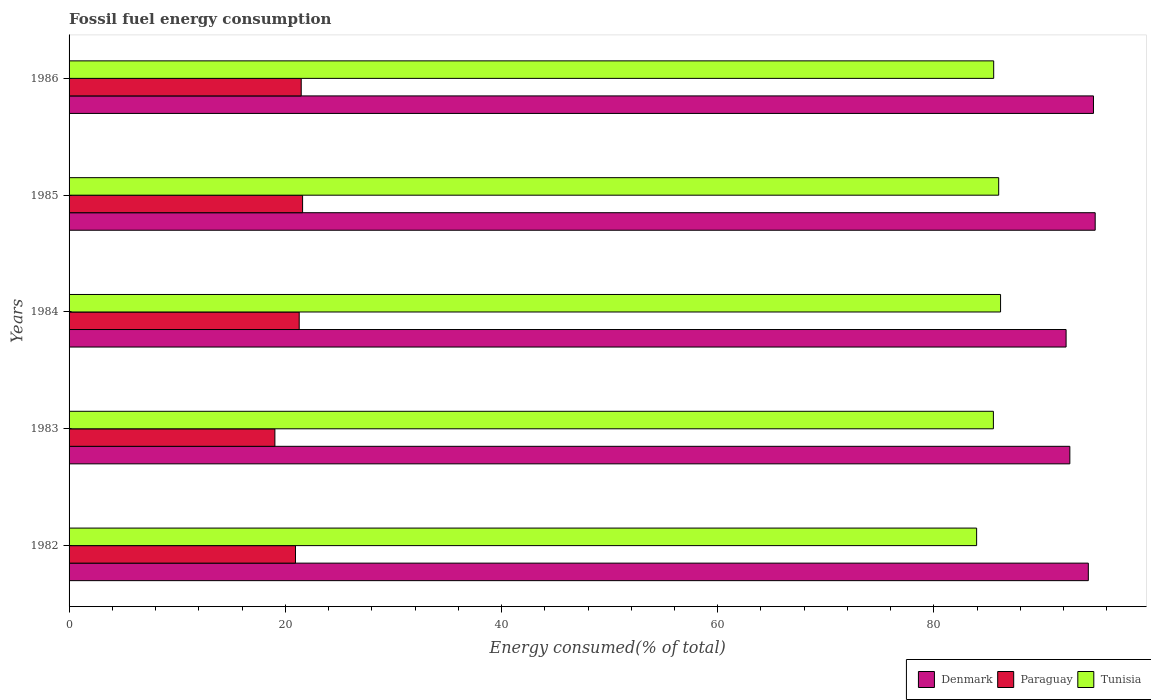How many different coloured bars are there?
Make the answer very short. 3. How many groups of bars are there?
Make the answer very short. 5. Are the number of bars per tick equal to the number of legend labels?
Offer a very short reply. Yes. Are the number of bars on each tick of the Y-axis equal?
Offer a terse response. Yes. How many bars are there on the 5th tick from the top?
Your response must be concise. 3. What is the label of the 5th group of bars from the top?
Make the answer very short. 1982. What is the percentage of energy consumed in Paraguay in 1985?
Your answer should be compact. 21.6. Across all years, what is the maximum percentage of energy consumed in Paraguay?
Give a very brief answer. 21.6. Across all years, what is the minimum percentage of energy consumed in Denmark?
Provide a short and direct response. 92.22. In which year was the percentage of energy consumed in Tunisia maximum?
Provide a succinct answer. 1984. In which year was the percentage of energy consumed in Denmark minimum?
Your answer should be very brief. 1984. What is the total percentage of energy consumed in Tunisia in the graph?
Your response must be concise. 427.12. What is the difference between the percentage of energy consumed in Paraguay in 1982 and that in 1986?
Provide a short and direct response. -0.53. What is the difference between the percentage of energy consumed in Denmark in 1985 and the percentage of energy consumed in Tunisia in 1983?
Offer a terse response. 9.42. What is the average percentage of energy consumed in Tunisia per year?
Provide a succinct answer. 85.42. In the year 1983, what is the difference between the percentage of energy consumed in Paraguay and percentage of energy consumed in Tunisia?
Ensure brevity in your answer.  -66.46. In how many years, is the percentage of energy consumed in Tunisia greater than 60 %?
Give a very brief answer. 5. What is the ratio of the percentage of energy consumed in Denmark in 1982 to that in 1984?
Offer a very short reply. 1.02. Is the percentage of energy consumed in Denmark in 1984 less than that in 1985?
Make the answer very short. Yes. Is the difference between the percentage of energy consumed in Paraguay in 1982 and 1984 greater than the difference between the percentage of energy consumed in Tunisia in 1982 and 1984?
Give a very brief answer. Yes. What is the difference between the highest and the second highest percentage of energy consumed in Tunisia?
Your answer should be very brief. 0.17. What is the difference between the highest and the lowest percentage of energy consumed in Tunisia?
Provide a succinct answer. 2.21. In how many years, is the percentage of energy consumed in Tunisia greater than the average percentage of energy consumed in Tunisia taken over all years?
Offer a terse response. 4. What does the 2nd bar from the top in 1985 represents?
Your answer should be very brief. Paraguay. What does the 2nd bar from the bottom in 1982 represents?
Give a very brief answer. Paraguay. How many bars are there?
Ensure brevity in your answer.  15. How many years are there in the graph?
Offer a terse response. 5. Does the graph contain grids?
Your answer should be compact. No. How are the legend labels stacked?
Offer a very short reply. Horizontal. What is the title of the graph?
Provide a short and direct response. Fossil fuel energy consumption. Does "Central Europe" appear as one of the legend labels in the graph?
Ensure brevity in your answer.  No. What is the label or title of the X-axis?
Give a very brief answer. Energy consumed(% of total). What is the Energy consumed(% of total) in Denmark in 1982?
Ensure brevity in your answer.  94.28. What is the Energy consumed(% of total) in Paraguay in 1982?
Keep it short and to the point. 20.94. What is the Energy consumed(% of total) in Tunisia in 1982?
Offer a terse response. 83.95. What is the Energy consumed(% of total) of Denmark in 1983?
Your answer should be compact. 92.57. What is the Energy consumed(% of total) in Paraguay in 1983?
Provide a succinct answer. 19.04. What is the Energy consumed(% of total) in Tunisia in 1983?
Give a very brief answer. 85.5. What is the Energy consumed(% of total) in Denmark in 1984?
Offer a terse response. 92.22. What is the Energy consumed(% of total) of Paraguay in 1984?
Provide a short and direct response. 21.29. What is the Energy consumed(% of total) of Tunisia in 1984?
Ensure brevity in your answer.  86.16. What is the Energy consumed(% of total) of Denmark in 1985?
Make the answer very short. 94.92. What is the Energy consumed(% of total) of Paraguay in 1985?
Your answer should be very brief. 21.6. What is the Energy consumed(% of total) of Tunisia in 1985?
Offer a terse response. 85.99. What is the Energy consumed(% of total) in Denmark in 1986?
Your response must be concise. 94.76. What is the Energy consumed(% of total) of Paraguay in 1986?
Your response must be concise. 21.47. What is the Energy consumed(% of total) of Tunisia in 1986?
Your answer should be compact. 85.53. Across all years, what is the maximum Energy consumed(% of total) in Denmark?
Offer a very short reply. 94.92. Across all years, what is the maximum Energy consumed(% of total) of Paraguay?
Provide a succinct answer. 21.6. Across all years, what is the maximum Energy consumed(% of total) in Tunisia?
Ensure brevity in your answer.  86.16. Across all years, what is the minimum Energy consumed(% of total) of Denmark?
Your answer should be compact. 92.22. Across all years, what is the minimum Energy consumed(% of total) in Paraguay?
Your answer should be compact. 19.04. Across all years, what is the minimum Energy consumed(% of total) of Tunisia?
Provide a short and direct response. 83.95. What is the total Energy consumed(% of total) of Denmark in the graph?
Provide a succinct answer. 468.75. What is the total Energy consumed(% of total) in Paraguay in the graph?
Your answer should be very brief. 104.35. What is the total Energy consumed(% of total) in Tunisia in the graph?
Provide a short and direct response. 427.12. What is the difference between the Energy consumed(% of total) of Denmark in 1982 and that in 1983?
Your response must be concise. 1.71. What is the difference between the Energy consumed(% of total) of Paraguay in 1982 and that in 1983?
Offer a very short reply. 1.91. What is the difference between the Energy consumed(% of total) of Tunisia in 1982 and that in 1983?
Ensure brevity in your answer.  -1.55. What is the difference between the Energy consumed(% of total) of Denmark in 1982 and that in 1984?
Keep it short and to the point. 2.06. What is the difference between the Energy consumed(% of total) in Paraguay in 1982 and that in 1984?
Provide a succinct answer. -0.34. What is the difference between the Energy consumed(% of total) in Tunisia in 1982 and that in 1984?
Offer a very short reply. -2.21. What is the difference between the Energy consumed(% of total) in Denmark in 1982 and that in 1985?
Offer a very short reply. -0.63. What is the difference between the Energy consumed(% of total) of Paraguay in 1982 and that in 1985?
Your answer should be compact. -0.66. What is the difference between the Energy consumed(% of total) in Tunisia in 1982 and that in 1985?
Make the answer very short. -2.04. What is the difference between the Energy consumed(% of total) in Denmark in 1982 and that in 1986?
Provide a succinct answer. -0.48. What is the difference between the Energy consumed(% of total) in Paraguay in 1982 and that in 1986?
Make the answer very short. -0.53. What is the difference between the Energy consumed(% of total) in Tunisia in 1982 and that in 1986?
Ensure brevity in your answer.  -1.58. What is the difference between the Energy consumed(% of total) of Denmark in 1983 and that in 1984?
Keep it short and to the point. 0.35. What is the difference between the Energy consumed(% of total) of Paraguay in 1983 and that in 1984?
Provide a succinct answer. -2.25. What is the difference between the Energy consumed(% of total) in Tunisia in 1983 and that in 1984?
Provide a short and direct response. -0.66. What is the difference between the Energy consumed(% of total) in Denmark in 1983 and that in 1985?
Your response must be concise. -2.34. What is the difference between the Energy consumed(% of total) of Paraguay in 1983 and that in 1985?
Ensure brevity in your answer.  -2.56. What is the difference between the Energy consumed(% of total) in Tunisia in 1983 and that in 1985?
Ensure brevity in your answer.  -0.49. What is the difference between the Energy consumed(% of total) in Denmark in 1983 and that in 1986?
Provide a short and direct response. -2.19. What is the difference between the Energy consumed(% of total) of Paraguay in 1983 and that in 1986?
Keep it short and to the point. -2.44. What is the difference between the Energy consumed(% of total) of Tunisia in 1983 and that in 1986?
Keep it short and to the point. -0.03. What is the difference between the Energy consumed(% of total) in Denmark in 1984 and that in 1985?
Provide a succinct answer. -2.69. What is the difference between the Energy consumed(% of total) in Paraguay in 1984 and that in 1985?
Your answer should be very brief. -0.31. What is the difference between the Energy consumed(% of total) of Tunisia in 1984 and that in 1985?
Ensure brevity in your answer.  0.17. What is the difference between the Energy consumed(% of total) in Denmark in 1984 and that in 1986?
Your answer should be very brief. -2.53. What is the difference between the Energy consumed(% of total) in Paraguay in 1984 and that in 1986?
Offer a very short reply. -0.19. What is the difference between the Energy consumed(% of total) of Tunisia in 1984 and that in 1986?
Keep it short and to the point. 0.64. What is the difference between the Energy consumed(% of total) of Denmark in 1985 and that in 1986?
Provide a short and direct response. 0.16. What is the difference between the Energy consumed(% of total) of Paraguay in 1985 and that in 1986?
Your response must be concise. 0.13. What is the difference between the Energy consumed(% of total) of Tunisia in 1985 and that in 1986?
Provide a succinct answer. 0.46. What is the difference between the Energy consumed(% of total) in Denmark in 1982 and the Energy consumed(% of total) in Paraguay in 1983?
Your answer should be compact. 75.24. What is the difference between the Energy consumed(% of total) of Denmark in 1982 and the Energy consumed(% of total) of Tunisia in 1983?
Ensure brevity in your answer.  8.78. What is the difference between the Energy consumed(% of total) in Paraguay in 1982 and the Energy consumed(% of total) in Tunisia in 1983?
Offer a very short reply. -64.55. What is the difference between the Energy consumed(% of total) of Denmark in 1982 and the Energy consumed(% of total) of Paraguay in 1984?
Give a very brief answer. 72.99. What is the difference between the Energy consumed(% of total) of Denmark in 1982 and the Energy consumed(% of total) of Tunisia in 1984?
Provide a succinct answer. 8.12. What is the difference between the Energy consumed(% of total) of Paraguay in 1982 and the Energy consumed(% of total) of Tunisia in 1984?
Ensure brevity in your answer.  -65.22. What is the difference between the Energy consumed(% of total) of Denmark in 1982 and the Energy consumed(% of total) of Paraguay in 1985?
Ensure brevity in your answer.  72.68. What is the difference between the Energy consumed(% of total) of Denmark in 1982 and the Energy consumed(% of total) of Tunisia in 1985?
Give a very brief answer. 8.29. What is the difference between the Energy consumed(% of total) in Paraguay in 1982 and the Energy consumed(% of total) in Tunisia in 1985?
Offer a terse response. -65.04. What is the difference between the Energy consumed(% of total) in Denmark in 1982 and the Energy consumed(% of total) in Paraguay in 1986?
Offer a very short reply. 72.81. What is the difference between the Energy consumed(% of total) of Denmark in 1982 and the Energy consumed(% of total) of Tunisia in 1986?
Your answer should be very brief. 8.75. What is the difference between the Energy consumed(% of total) of Paraguay in 1982 and the Energy consumed(% of total) of Tunisia in 1986?
Your response must be concise. -64.58. What is the difference between the Energy consumed(% of total) in Denmark in 1983 and the Energy consumed(% of total) in Paraguay in 1984?
Keep it short and to the point. 71.28. What is the difference between the Energy consumed(% of total) of Denmark in 1983 and the Energy consumed(% of total) of Tunisia in 1984?
Your response must be concise. 6.41. What is the difference between the Energy consumed(% of total) of Paraguay in 1983 and the Energy consumed(% of total) of Tunisia in 1984?
Give a very brief answer. -67.12. What is the difference between the Energy consumed(% of total) of Denmark in 1983 and the Energy consumed(% of total) of Paraguay in 1985?
Provide a succinct answer. 70.97. What is the difference between the Energy consumed(% of total) of Denmark in 1983 and the Energy consumed(% of total) of Tunisia in 1985?
Ensure brevity in your answer.  6.58. What is the difference between the Energy consumed(% of total) of Paraguay in 1983 and the Energy consumed(% of total) of Tunisia in 1985?
Provide a succinct answer. -66.95. What is the difference between the Energy consumed(% of total) of Denmark in 1983 and the Energy consumed(% of total) of Paraguay in 1986?
Your answer should be very brief. 71.1. What is the difference between the Energy consumed(% of total) of Denmark in 1983 and the Energy consumed(% of total) of Tunisia in 1986?
Provide a short and direct response. 7.04. What is the difference between the Energy consumed(% of total) in Paraguay in 1983 and the Energy consumed(% of total) in Tunisia in 1986?
Give a very brief answer. -66.49. What is the difference between the Energy consumed(% of total) of Denmark in 1984 and the Energy consumed(% of total) of Paraguay in 1985?
Offer a very short reply. 70.62. What is the difference between the Energy consumed(% of total) of Denmark in 1984 and the Energy consumed(% of total) of Tunisia in 1985?
Your answer should be very brief. 6.24. What is the difference between the Energy consumed(% of total) in Paraguay in 1984 and the Energy consumed(% of total) in Tunisia in 1985?
Your response must be concise. -64.7. What is the difference between the Energy consumed(% of total) of Denmark in 1984 and the Energy consumed(% of total) of Paraguay in 1986?
Your answer should be very brief. 70.75. What is the difference between the Energy consumed(% of total) of Denmark in 1984 and the Energy consumed(% of total) of Tunisia in 1986?
Your answer should be very brief. 6.7. What is the difference between the Energy consumed(% of total) in Paraguay in 1984 and the Energy consumed(% of total) in Tunisia in 1986?
Keep it short and to the point. -64.24. What is the difference between the Energy consumed(% of total) of Denmark in 1985 and the Energy consumed(% of total) of Paraguay in 1986?
Your answer should be compact. 73.44. What is the difference between the Energy consumed(% of total) of Denmark in 1985 and the Energy consumed(% of total) of Tunisia in 1986?
Your answer should be compact. 9.39. What is the difference between the Energy consumed(% of total) in Paraguay in 1985 and the Energy consumed(% of total) in Tunisia in 1986?
Keep it short and to the point. -63.93. What is the average Energy consumed(% of total) in Denmark per year?
Make the answer very short. 93.75. What is the average Energy consumed(% of total) in Paraguay per year?
Ensure brevity in your answer.  20.87. What is the average Energy consumed(% of total) in Tunisia per year?
Ensure brevity in your answer.  85.42. In the year 1982, what is the difference between the Energy consumed(% of total) in Denmark and Energy consumed(% of total) in Paraguay?
Offer a terse response. 73.34. In the year 1982, what is the difference between the Energy consumed(% of total) in Denmark and Energy consumed(% of total) in Tunisia?
Provide a succinct answer. 10.33. In the year 1982, what is the difference between the Energy consumed(% of total) of Paraguay and Energy consumed(% of total) of Tunisia?
Your answer should be compact. -63. In the year 1983, what is the difference between the Energy consumed(% of total) in Denmark and Energy consumed(% of total) in Paraguay?
Make the answer very short. 73.53. In the year 1983, what is the difference between the Energy consumed(% of total) of Denmark and Energy consumed(% of total) of Tunisia?
Your response must be concise. 7.07. In the year 1983, what is the difference between the Energy consumed(% of total) in Paraguay and Energy consumed(% of total) in Tunisia?
Make the answer very short. -66.46. In the year 1984, what is the difference between the Energy consumed(% of total) in Denmark and Energy consumed(% of total) in Paraguay?
Offer a terse response. 70.94. In the year 1984, what is the difference between the Energy consumed(% of total) of Denmark and Energy consumed(% of total) of Tunisia?
Your answer should be compact. 6.06. In the year 1984, what is the difference between the Energy consumed(% of total) in Paraguay and Energy consumed(% of total) in Tunisia?
Make the answer very short. -64.87. In the year 1985, what is the difference between the Energy consumed(% of total) of Denmark and Energy consumed(% of total) of Paraguay?
Ensure brevity in your answer.  73.31. In the year 1985, what is the difference between the Energy consumed(% of total) in Denmark and Energy consumed(% of total) in Tunisia?
Provide a succinct answer. 8.93. In the year 1985, what is the difference between the Energy consumed(% of total) of Paraguay and Energy consumed(% of total) of Tunisia?
Offer a very short reply. -64.39. In the year 1986, what is the difference between the Energy consumed(% of total) in Denmark and Energy consumed(% of total) in Paraguay?
Provide a short and direct response. 73.28. In the year 1986, what is the difference between the Energy consumed(% of total) in Denmark and Energy consumed(% of total) in Tunisia?
Your answer should be very brief. 9.23. In the year 1986, what is the difference between the Energy consumed(% of total) of Paraguay and Energy consumed(% of total) of Tunisia?
Provide a succinct answer. -64.05. What is the ratio of the Energy consumed(% of total) in Denmark in 1982 to that in 1983?
Offer a very short reply. 1.02. What is the ratio of the Energy consumed(% of total) in Paraguay in 1982 to that in 1983?
Make the answer very short. 1.1. What is the ratio of the Energy consumed(% of total) in Tunisia in 1982 to that in 1983?
Your answer should be compact. 0.98. What is the ratio of the Energy consumed(% of total) in Denmark in 1982 to that in 1984?
Your answer should be compact. 1.02. What is the ratio of the Energy consumed(% of total) of Paraguay in 1982 to that in 1984?
Your answer should be very brief. 0.98. What is the ratio of the Energy consumed(% of total) in Tunisia in 1982 to that in 1984?
Your answer should be very brief. 0.97. What is the ratio of the Energy consumed(% of total) of Denmark in 1982 to that in 1985?
Your answer should be compact. 0.99. What is the ratio of the Energy consumed(% of total) in Paraguay in 1982 to that in 1985?
Keep it short and to the point. 0.97. What is the ratio of the Energy consumed(% of total) in Tunisia in 1982 to that in 1985?
Keep it short and to the point. 0.98. What is the ratio of the Energy consumed(% of total) in Paraguay in 1982 to that in 1986?
Offer a very short reply. 0.98. What is the ratio of the Energy consumed(% of total) in Tunisia in 1982 to that in 1986?
Make the answer very short. 0.98. What is the ratio of the Energy consumed(% of total) of Paraguay in 1983 to that in 1984?
Keep it short and to the point. 0.89. What is the ratio of the Energy consumed(% of total) in Denmark in 1983 to that in 1985?
Make the answer very short. 0.98. What is the ratio of the Energy consumed(% of total) of Paraguay in 1983 to that in 1985?
Your response must be concise. 0.88. What is the ratio of the Energy consumed(% of total) in Denmark in 1983 to that in 1986?
Make the answer very short. 0.98. What is the ratio of the Energy consumed(% of total) in Paraguay in 1983 to that in 1986?
Offer a very short reply. 0.89. What is the ratio of the Energy consumed(% of total) of Tunisia in 1983 to that in 1986?
Make the answer very short. 1. What is the ratio of the Energy consumed(% of total) of Denmark in 1984 to that in 1985?
Provide a short and direct response. 0.97. What is the ratio of the Energy consumed(% of total) in Paraguay in 1984 to that in 1985?
Provide a short and direct response. 0.99. What is the ratio of the Energy consumed(% of total) in Tunisia in 1984 to that in 1985?
Make the answer very short. 1. What is the ratio of the Energy consumed(% of total) of Denmark in 1984 to that in 1986?
Make the answer very short. 0.97. What is the ratio of the Energy consumed(% of total) of Paraguay in 1984 to that in 1986?
Make the answer very short. 0.99. What is the ratio of the Energy consumed(% of total) in Tunisia in 1984 to that in 1986?
Give a very brief answer. 1.01. What is the ratio of the Energy consumed(% of total) of Denmark in 1985 to that in 1986?
Offer a terse response. 1. What is the ratio of the Energy consumed(% of total) of Paraguay in 1985 to that in 1986?
Give a very brief answer. 1.01. What is the ratio of the Energy consumed(% of total) of Tunisia in 1985 to that in 1986?
Ensure brevity in your answer.  1.01. What is the difference between the highest and the second highest Energy consumed(% of total) in Denmark?
Ensure brevity in your answer.  0.16. What is the difference between the highest and the second highest Energy consumed(% of total) in Paraguay?
Keep it short and to the point. 0.13. What is the difference between the highest and the second highest Energy consumed(% of total) in Tunisia?
Give a very brief answer. 0.17. What is the difference between the highest and the lowest Energy consumed(% of total) of Denmark?
Provide a succinct answer. 2.69. What is the difference between the highest and the lowest Energy consumed(% of total) of Paraguay?
Give a very brief answer. 2.56. What is the difference between the highest and the lowest Energy consumed(% of total) of Tunisia?
Offer a very short reply. 2.21. 